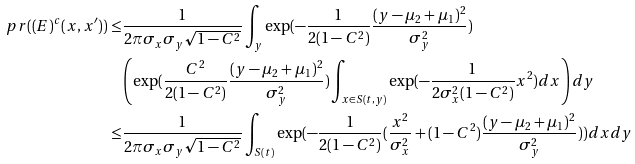Convert formula to latex. <formula><loc_0><loc_0><loc_500><loc_500>\ p r ( ( E ) ^ { c } ( x , x ^ { \prime } ) ) \leq & \frac { 1 } { 2 \pi \sigma _ { x } \sigma _ { y } \sqrt { 1 - C ^ { 2 } } } \int _ { y } \exp ( - \frac { 1 } { 2 ( 1 - C ^ { 2 } ) } \frac { ( y - \mu _ { 2 } + \mu _ { 1 } ) ^ { 2 } } { \sigma _ { y } ^ { 2 } } ) \\ & \left ( \exp ( \frac { C ^ { 2 } } { 2 ( 1 - C ^ { 2 } ) } \frac { ( y - \mu _ { 2 } + \mu _ { 1 } ) ^ { 2 } } { \sigma _ { y } ^ { 2 } } ) \int _ { x \in S ( t , y ) } \exp ( - \frac { 1 } { 2 \sigma _ { x } ^ { 2 } ( 1 - C ^ { 2 } ) } x ^ { 2 } ) d x \right ) d y \\ \leq & \frac { 1 } { 2 \pi \sigma _ { x } \sigma _ { y } \sqrt { 1 - C ^ { 2 } } } \int _ { S ( t ) } \exp ( - \frac { 1 } { 2 ( 1 - C ^ { 2 } ) } ( \frac { x ^ { 2 } } { \sigma _ { x } ^ { 2 } } + ( 1 - C ^ { 2 } ) \frac { ( y - \mu _ { 2 } + \mu _ { 1 } ) ^ { 2 } } { \sigma _ { y } ^ { 2 } } ) ) d x d y</formula> 